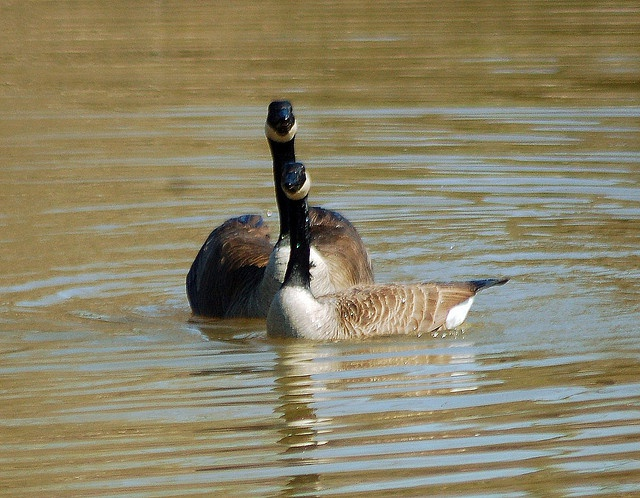Describe the objects in this image and their specific colors. I can see bird in olive, black, gray, and tan tones and bird in olive, black, tan, lightgray, and darkgray tones in this image. 